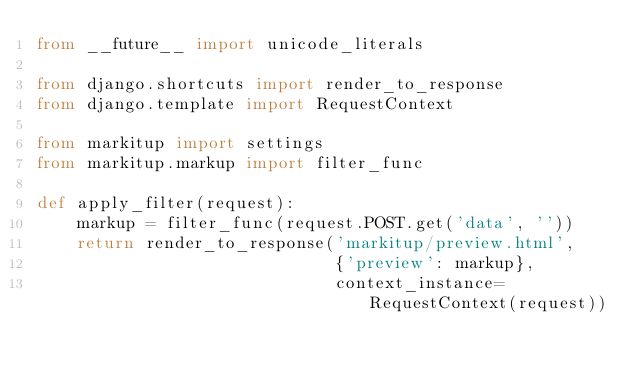Convert code to text. <code><loc_0><loc_0><loc_500><loc_500><_Python_>from __future__ import unicode_literals

from django.shortcuts import render_to_response
from django.template import RequestContext

from markitup import settings
from markitup.markup import filter_func

def apply_filter(request):
    markup = filter_func(request.POST.get('data', ''))
    return render_to_response('markitup/preview.html',
                              {'preview': markup},
                              context_instance=RequestContext(request))
</code> 